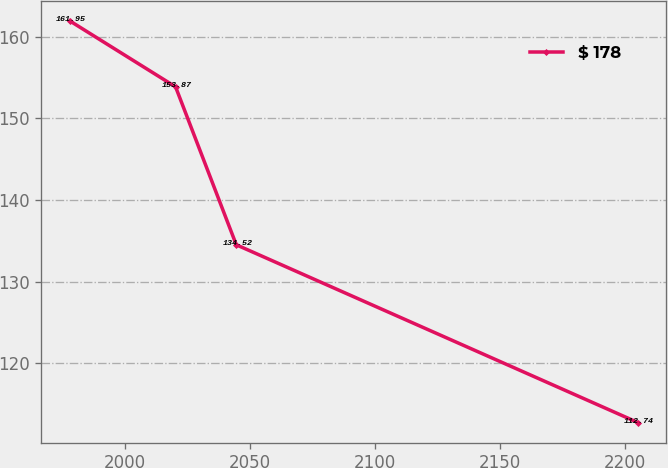Convert chart to OTSL. <chart><loc_0><loc_0><loc_500><loc_500><line_chart><ecel><fcel>$ 178<nl><fcel>1977.95<fcel>161.95<nl><fcel>2020.26<fcel>153.87<nl><fcel>2044.54<fcel>134.52<nl><fcel>2205.21<fcel>112.74<nl></chart> 